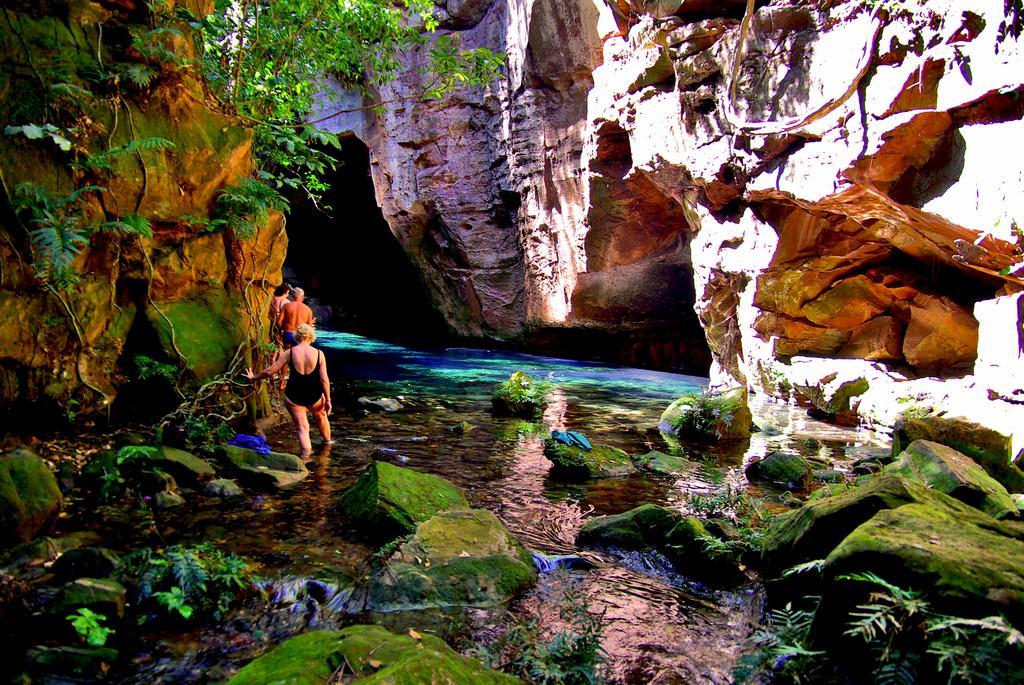Please provide a concise description of this image. In this picture we can see people,here we can see rocks,trees. 